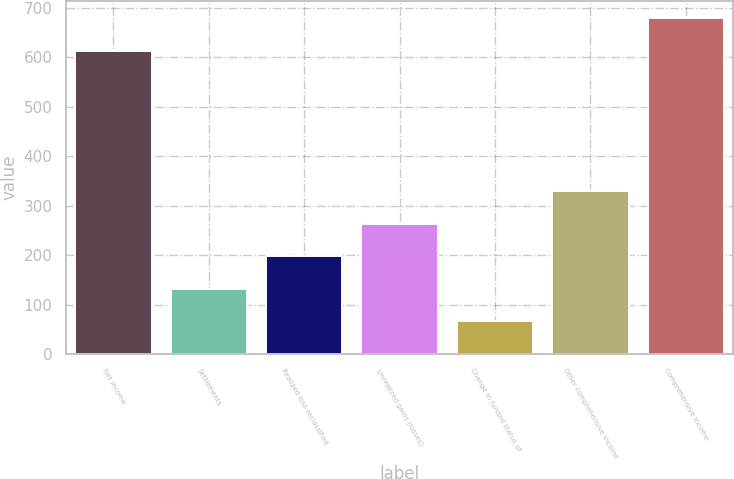<chart> <loc_0><loc_0><loc_500><loc_500><bar_chart><fcel>Net income<fcel>Settlements<fcel>Realized loss reclassified<fcel>Unrealized gains (losses)<fcel>Change in funded status of<fcel>Other comprehensive income<fcel>Comprehensive income<nl><fcel>613.2<fcel>132.06<fcel>197.79<fcel>263.52<fcel>66.33<fcel>329.25<fcel>678.93<nl></chart> 